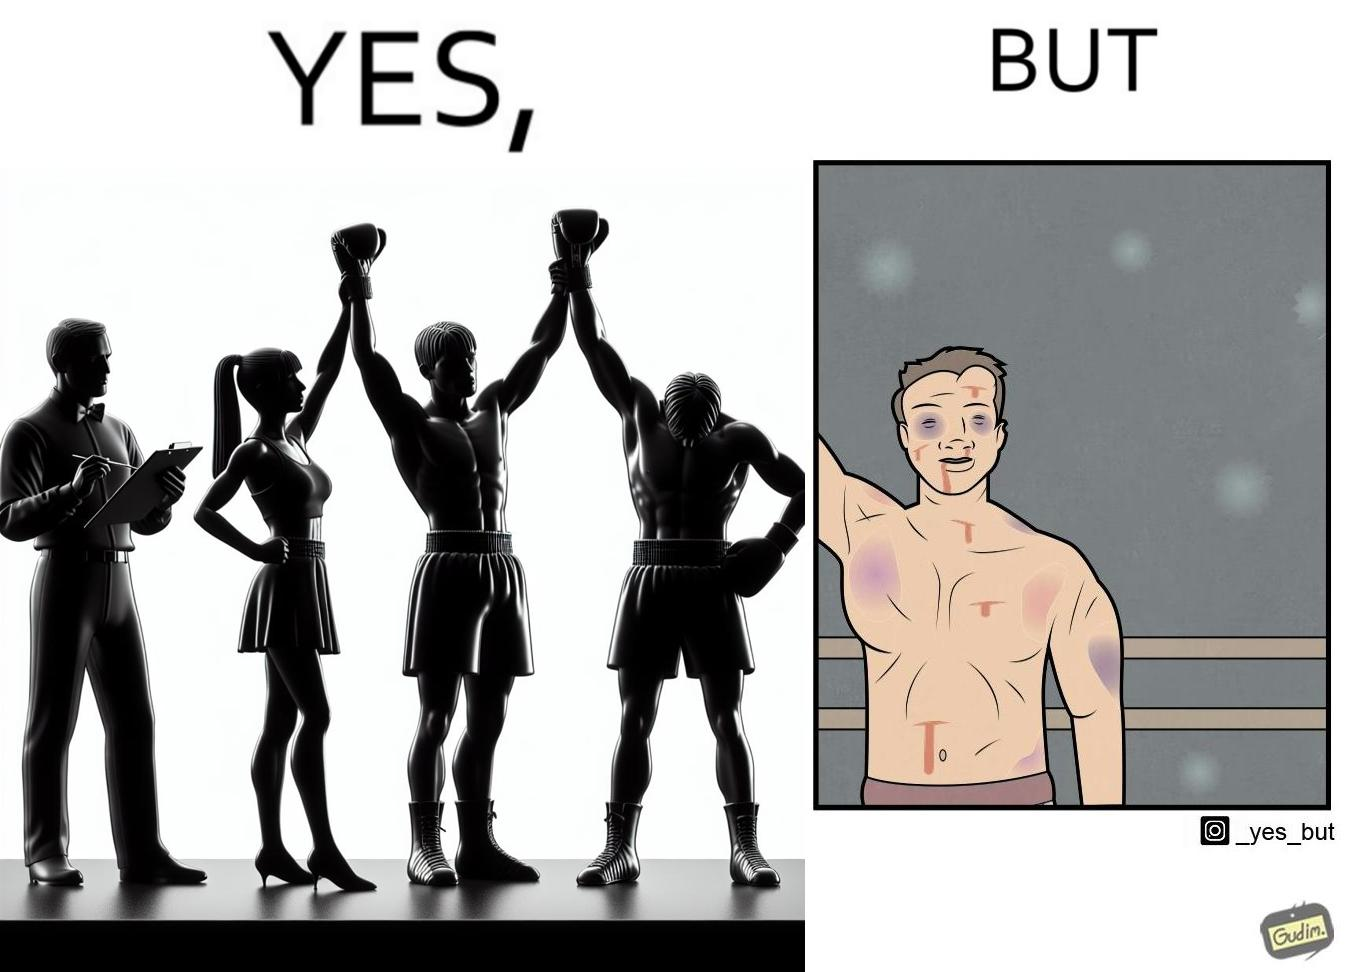Would you classify this image as satirical? Yes, this image is satirical. 